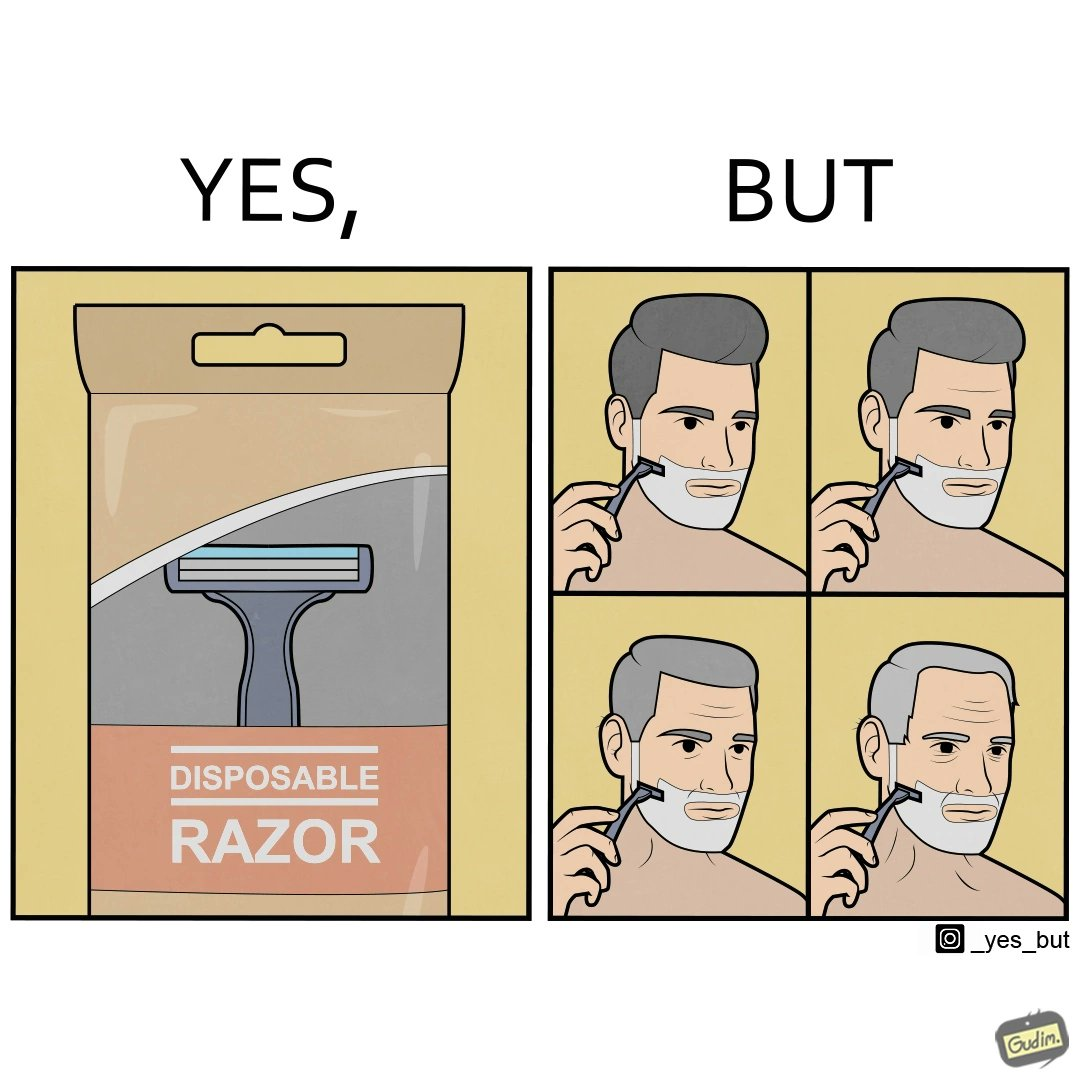What is shown in this image? The images are funny since the show people end up using disposable razors for so long that they need not dispose it anymore. 